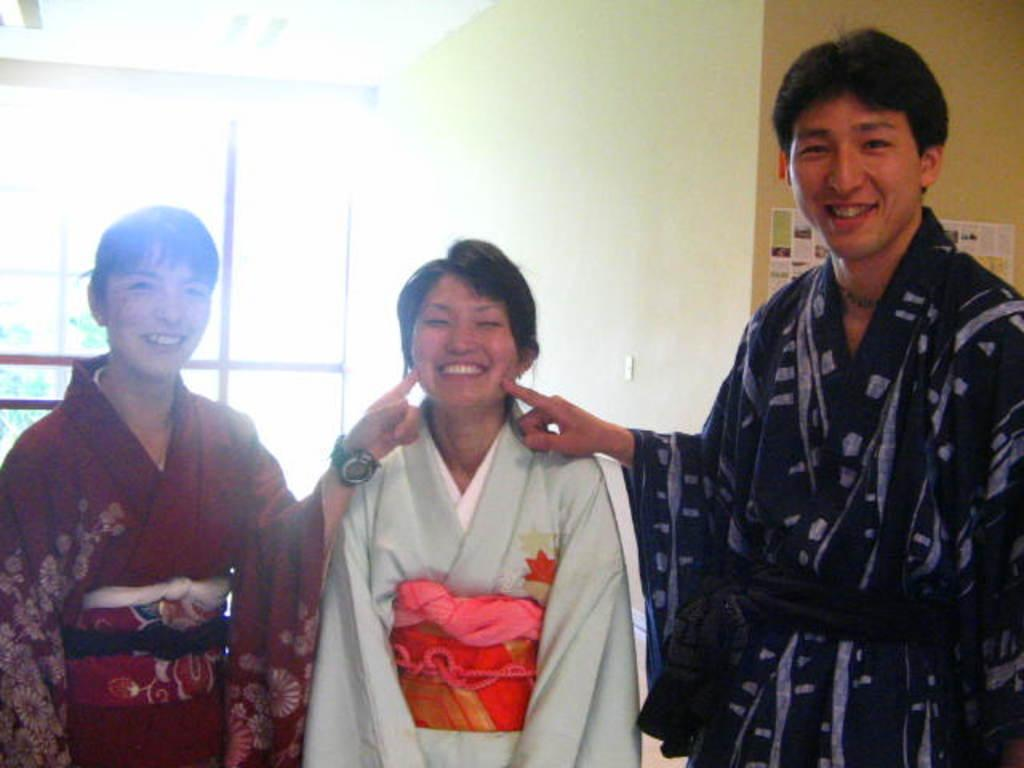How many people are present in the image? There are three people in the image. What is visible on the wall in the image? There is a poster on the wall. Where is the throne located in the image? There is no throne present in the image. Is there a bike visible in the image? There is no bike visible in the image. Can you see any steam coming from any objects in the image? There is no steam present in the image. 